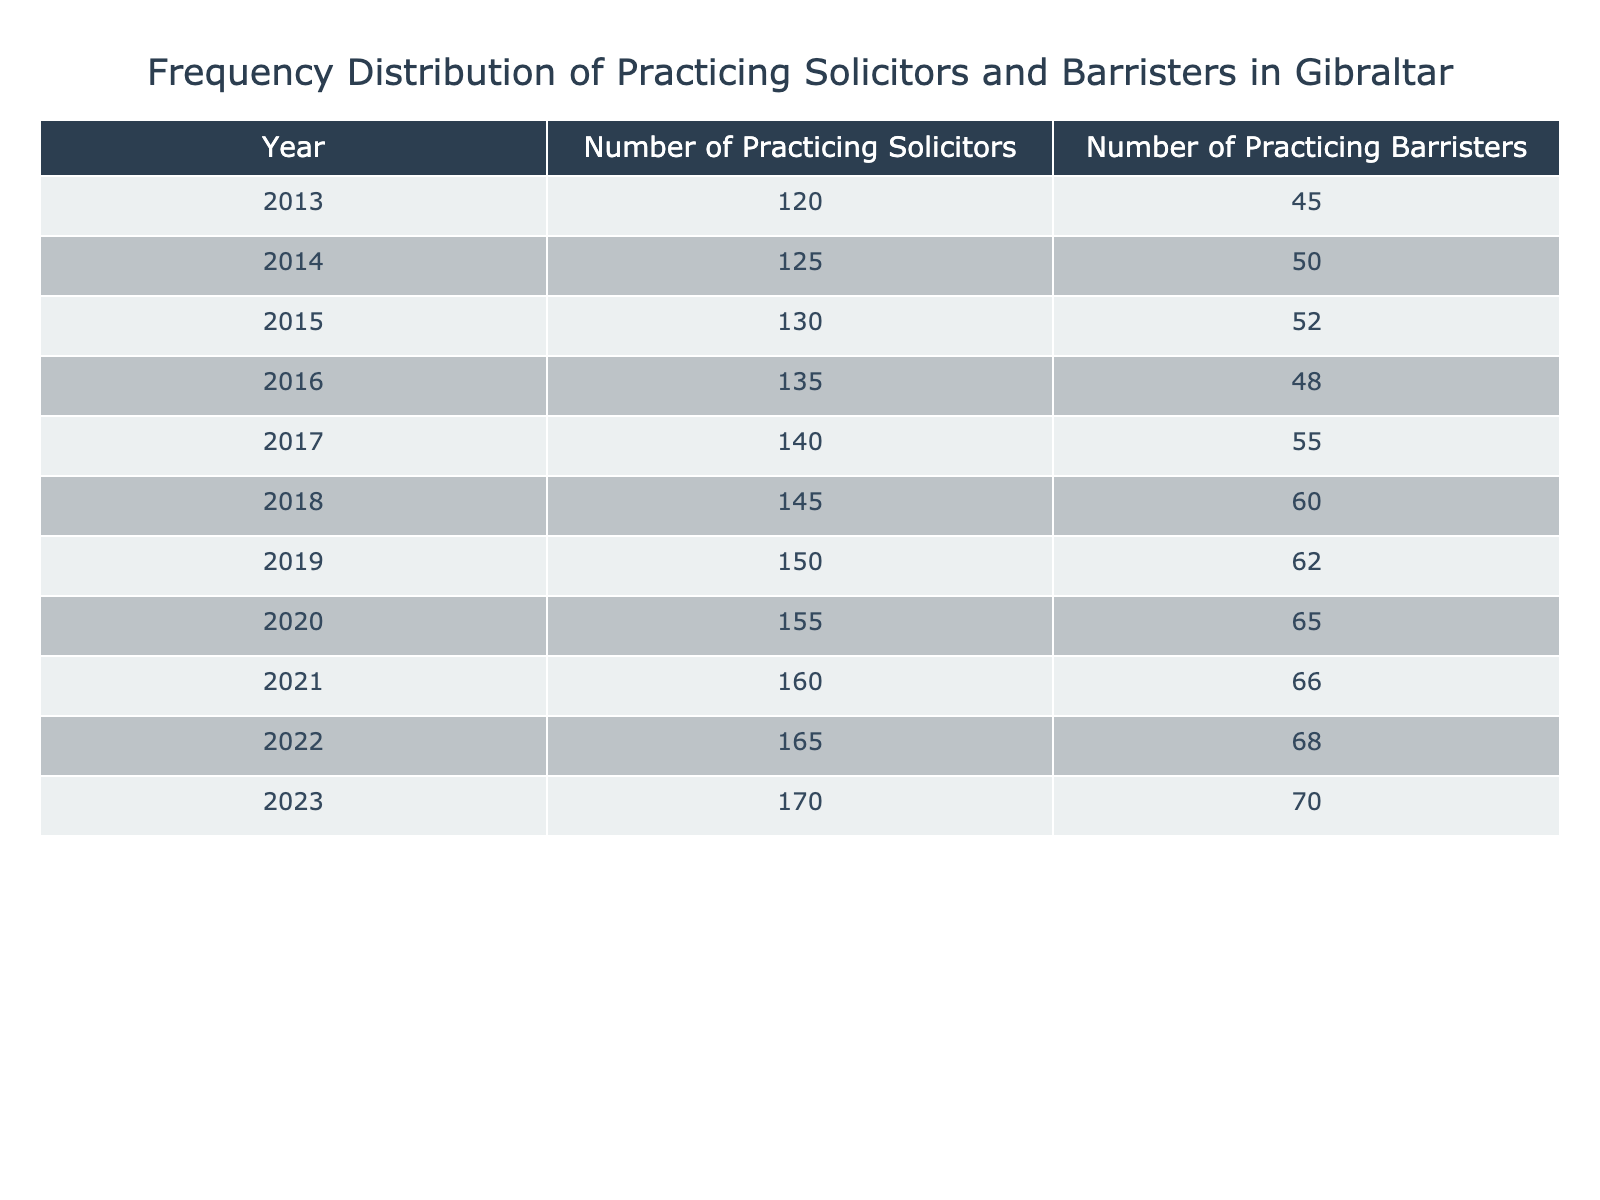What was the total number of practicing solicitors in Gibraltar in 2019? By referring to the table, we see that in 2019, the number of practicing solicitors is listed as 150.
Answer: 150 What was the number of practicing barristers in 2021? The table shows that in 2021, the number of practicing barristers was 66.
Answer: 66 What is the average number of practicing solicitors over the last decade? To get the average, we need to sum up the number of practicing solicitors from 2013 to 2023: 120 + 125 + 130 + 135 + 140 + 145 + 150 + 155 + 160 + 165 + 170 = 1,685. Then, divide by 11 (the number of years): 1,685 / 11 = 153.18. So the average is approximately 153.18.
Answer: 153.18 Was there an increase or decrease in the number of practicing barristers between 2013 and 2023? In 2013, there were 45 practicing barristers, and in 2023, there are 70. Since 70 is greater than 45, there was an increase.
Answer: Yes How many more practicing solicitors were there in 2023 compared to 2015? In 2023, there were 170 practicing solicitors, and in 2015, there were 130. The difference is 170 - 130 = 40.
Answer: 40 What was the year with the highest number of practicing barristers, and how many were there? Looking at the table, the highest number of practicing barristers occurred in 2023 with 70 barristers.
Answer: 2023, 70 What is the percentage increase in the number of practicing solicitors from 2013 to 2023? In 2013, there were 120 practicing solicitors and in 2023, there are 170. The increase is 170 - 120 = 50. To find the percentage increase, divide the increase by the original number and multiply by 100: (50 / 120) * 100 = 41.67%.
Answer: 41.67% Which year saw the smallest increase in the number of practicing solicitors compared to the previous year? By examining the yearly changes, we see the smallest increase occurred between 2016 and 2017, where the number went from 135 to 140, resulting in an increase of only 5.
Answer: 2016 to 2017 What is the total number of solicitors and barristers practicing in Gibraltar in 2020? In 2020, the table shows 155 practicing solicitors and 65 practicing barristers. The total is 155 + 65 = 220.
Answer: 220 